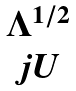<formula> <loc_0><loc_0><loc_500><loc_500>\begin{matrix} \Lambda ^ { 1 / 2 } \\ j U \end{matrix}</formula> 